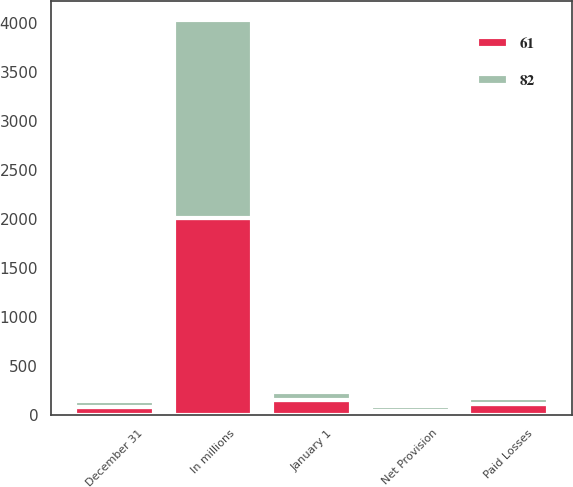Convert chart to OTSL. <chart><loc_0><loc_0><loc_500><loc_500><stacked_bar_chart><ecel><fcel>In millions<fcel>January 1<fcel>Paid Losses<fcel>Net Provision<fcel>December 31<nl><fcel>82<fcel>2012<fcel>82<fcel>66<fcel>45<fcel>61<nl><fcel>61<fcel>2011<fcel>150<fcel>109<fcel>41<fcel>82<nl></chart> 